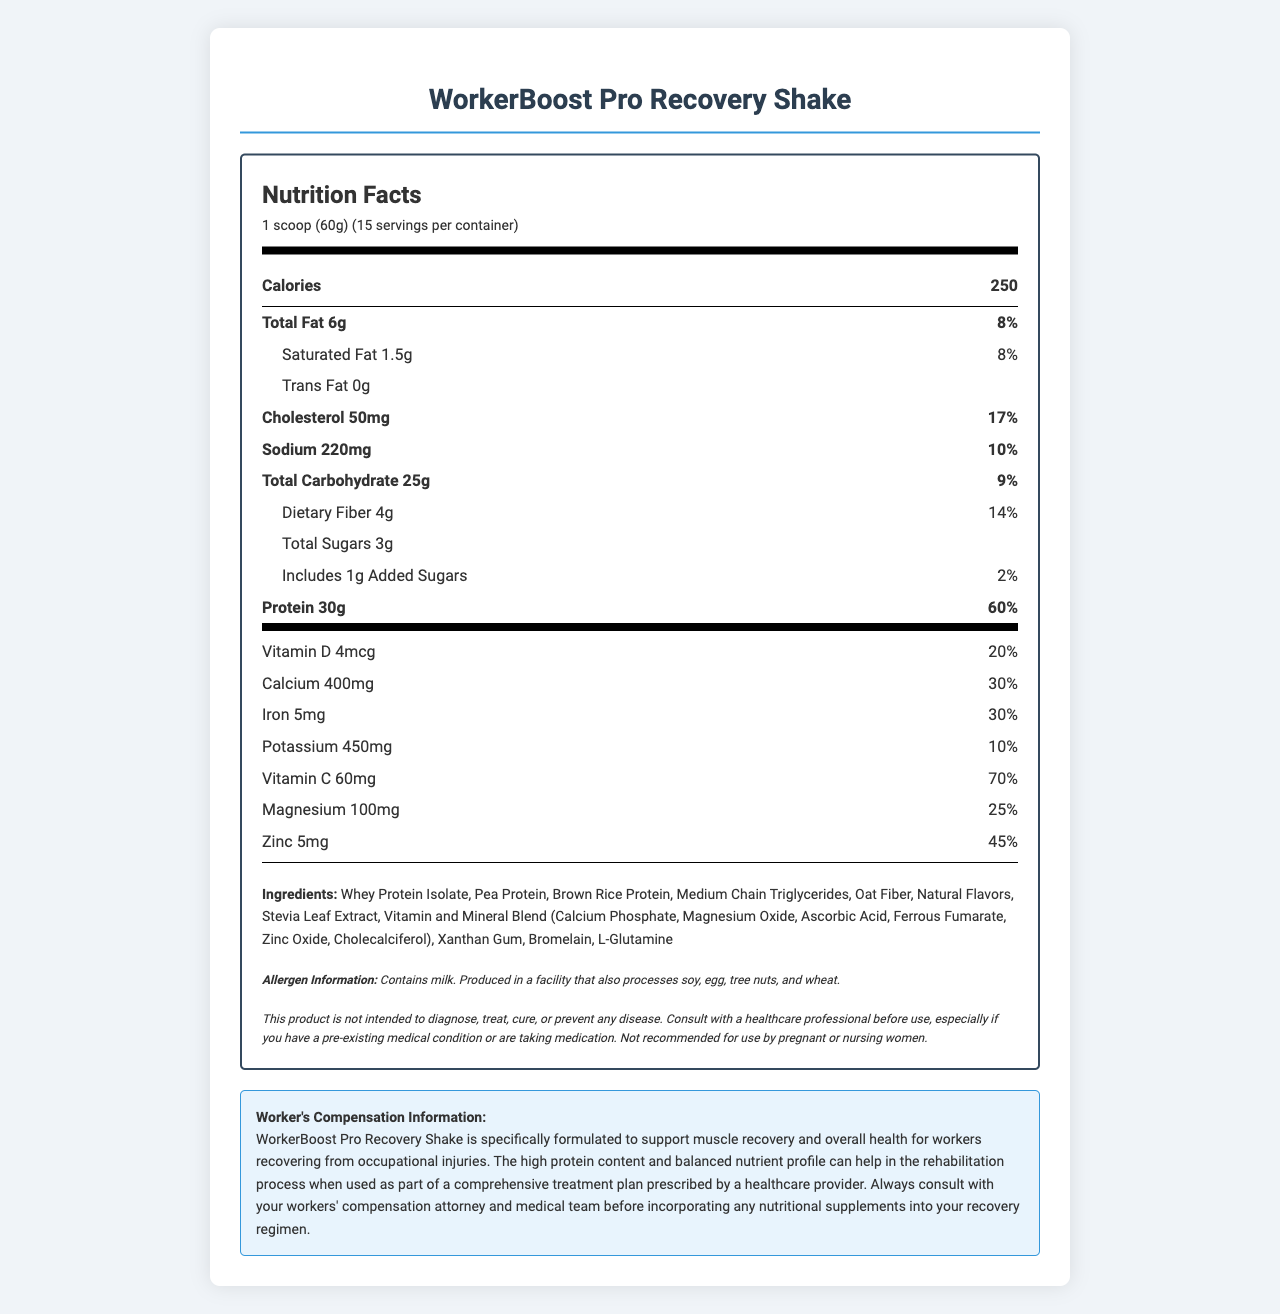what is the serving size? The serving size is listed in the "Nutrition Facts" section under "serving info."
Answer: 1 scoop (60g) How many servings are there per container? The number of servings per container is listed under "serving info."
Answer: 15 what is the amount of protein per serving? The protein amount per serving is listed under the "Protein" section.
Answer: 30g What is the percentage of the daily value for calcium? The percentage daily value for calcium is listed under the "Calcium" section.
Answer: 30% What type of protein ingredients are included in this shake? The protein ingredients are listed in the "Ingredients" section.
Answer: Whey Protein Isolate, Pea Protein, Brown Rice Protein how much sodium is in one serving? The sodium content is listed in the "Sodium" section.
Answer: 220mg What is the total number of calories per serving? The calorie content is listed under "Calories info."
Answer: 250 What allergens are mentioned? The allergen information is listed in the "Allergen Information" section.
Answer: Contains milk. Produced in a facility that also processes soy, egg, tree nuts, and wheat. What is the percentage of daily value for Vitamin D? The percentage daily value for Vitamin D is listed in the "Vitamin D" section.
Answer: 20% Does this product contain any trans fat? The amount of trans fat is listed as "0g" in the "Trans Fat" section.
Answer: No Which of the following vitamins is NOT listed on the label?
A. Vitamin A
B. Vitamin C
C. Vitamin D Vitamin A is not mentioned, whereas Vitamin C and Vitamin D are listed with their amounts and daily values on the label.
Answer: A. Vitamin A Which nutrient has the highest percentage of daily value?
A. Protein
B. Vitamin C
C. Calcium Protein has a daily value percentage of 60%, which is higher than Vitamin C (70%) and Calcium (30%).
Answer: A. Protein Does the shake contain any iron? The amount of iron and its daily value percentage are listed in the "Iron" section.
Answer: Yes What should workers do before incorporating this shake into their recovery regimen? The "Worker's Compensation Information" section advises consulting with a workers' compensation attorney and medical team.
Answer: Consult with a workers' compensation attorney and medical team Summarize the main purpose of the WorkerBoost Pro Recovery Shake document. The document is a comprehensive nutrition fact sheet that aims to inform consumers, particularly workers recovering from injuries, about the nutritional benefits and considerations of the WorkerBoost Pro Recovery Shake.
Answer: The document provides detailed nutrition facts and ingredients for the WorkerBoost Pro Recovery Shake, highlighting its high protein content and nutrients designed to support muscle recovery for workers recovering from occupational injuries. It includes serving size, calorie count, main nutrients, allergen information, legal disclaimer, and specific guidance for use in workers' compensation cases. What is the legal disclaimer about using this product? The legal disclaimer is listed towards the end of the document, providing necessary cautions about using the product.
Answer: This product is not intended to diagnose, treat, cure, or prevent any disease. Consult with a healthcare professional before use, especially if you have a pre-existing medical condition or are taking medication. Not recommended for use by pregnant or nursing women. Can the exact manufacturing process for this product be determined from the document? The document does not provide details about the manufacturing process, only some information about allergens and the facility in which the product is produced.
Answer: Not enough information 